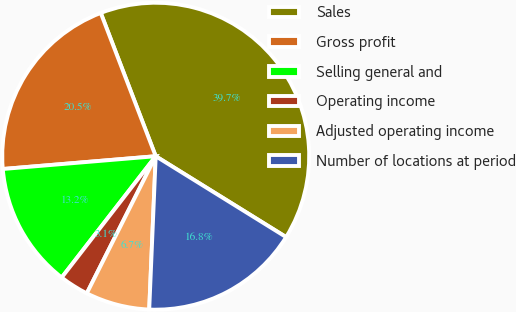Convert chart. <chart><loc_0><loc_0><loc_500><loc_500><pie_chart><fcel>Sales<fcel>Gross profit<fcel>Selling general and<fcel>Operating income<fcel>Adjusted operating income<fcel>Number of locations at period<nl><fcel>39.67%<fcel>20.5%<fcel>13.18%<fcel>3.08%<fcel>6.74%<fcel>16.84%<nl></chart> 